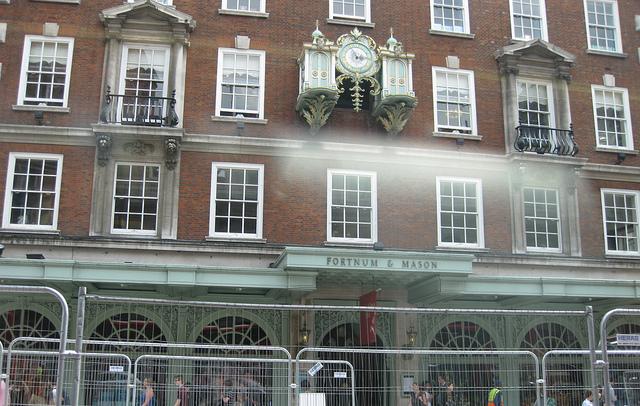Is this a government building?
Answer briefly. No. Where is there a red flag hanging?
Quick response, please. Entrance. What stands between the street and the sidewalk in front of the building?
Write a very short answer. Fence. What shape are the windows?
Concise answer only. Rectangle. 